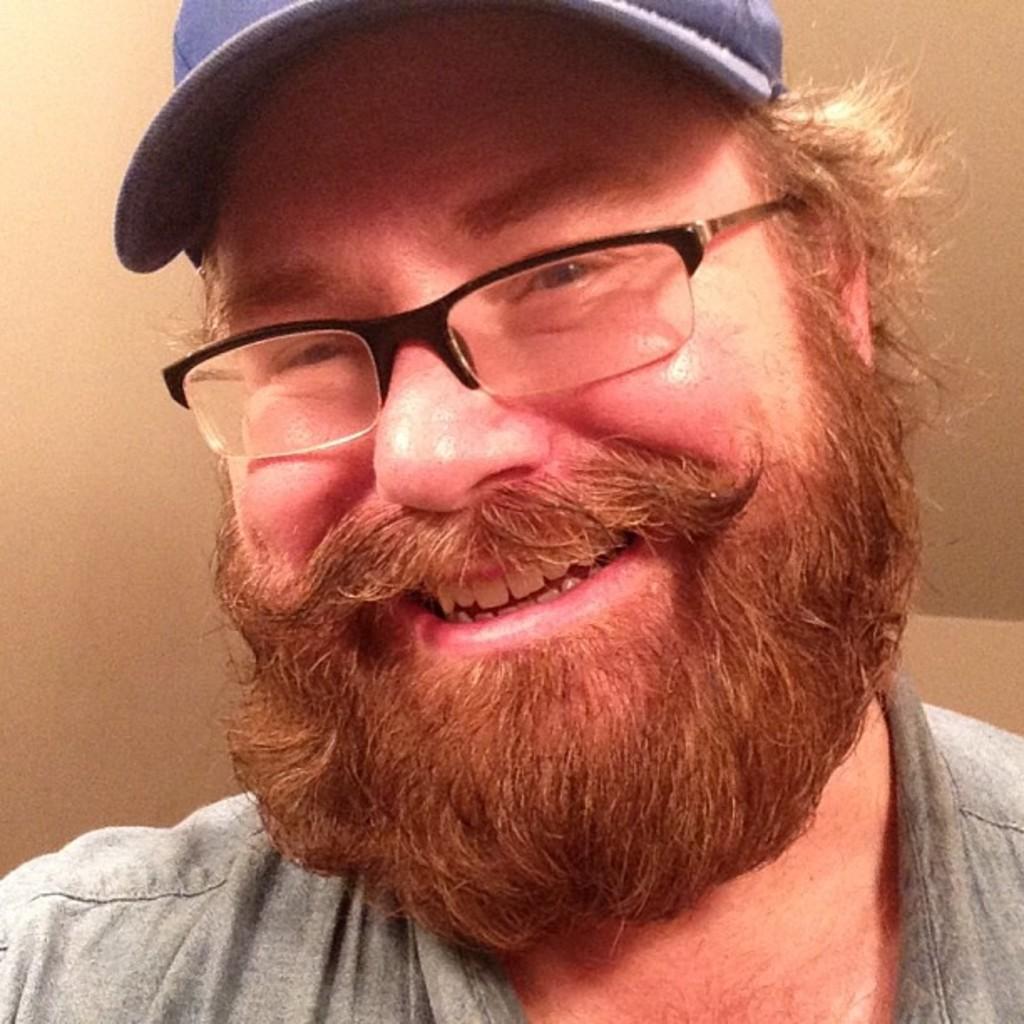In one or two sentences, can you explain what this image depicts? In this picture we can see a man, he is smiling, he wore spectacles and a cap. 